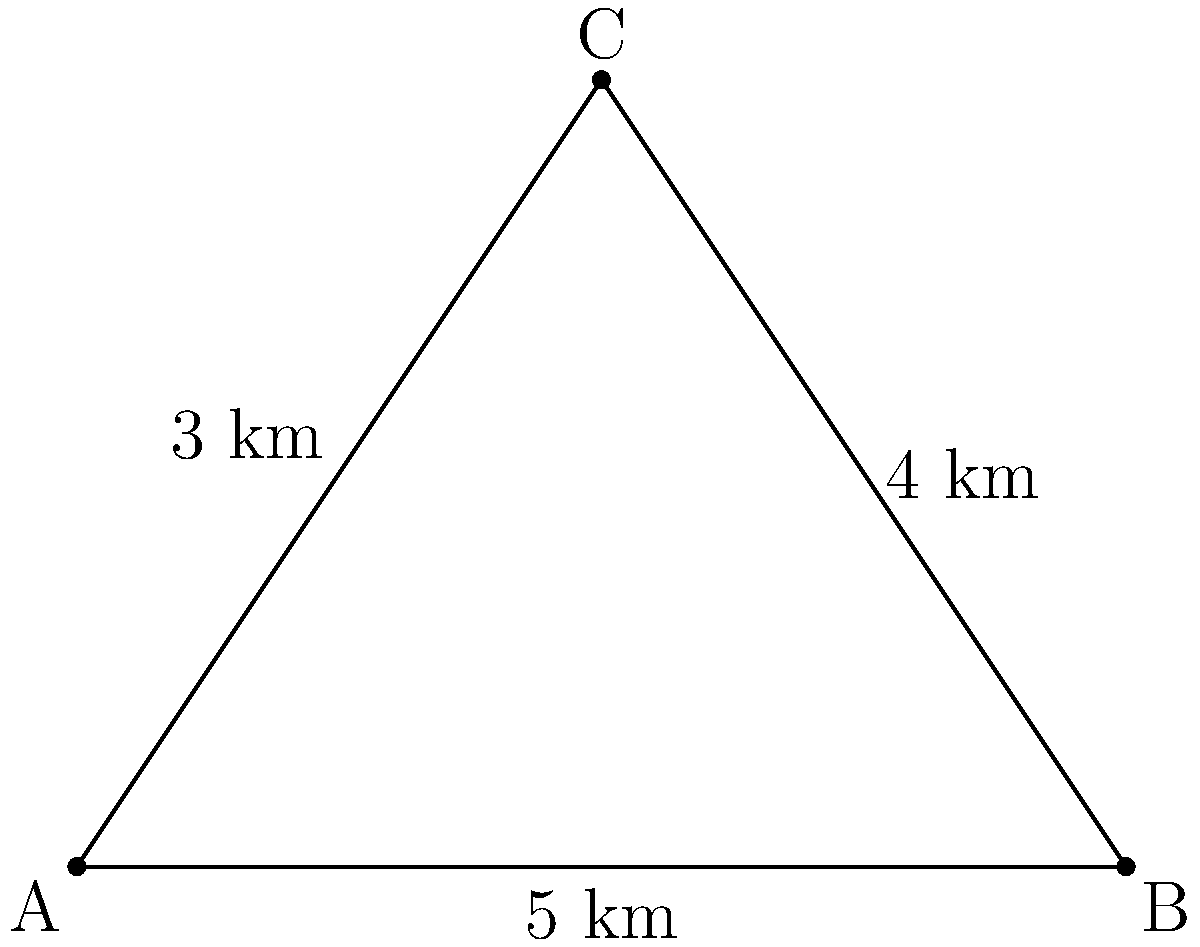In the desert near Riyadh, two roads intersect at point C. The first road runs from A to B, and the second road connects C to A. If the distance from A to B is 5 km, from B to C is 4 km, and from A to C is 3 km, what is the angle between these two roads at point C? To find the angle between the two roads at point C, we can use the law of cosines. Here's how:

1) Let's denote the angle at C as $\theta$.

2) The law of cosines states: 
   $c^2 = a^2 + b^2 - 2ab \cos(C)$
   where $c$ is the side opposite to angle C, and $a$ and $b$ are the other two sides.

3) In our case:
   $a = 3$ km (AC)
   $b = 4$ km (BC)
   $c = 5$ km (AB)

4) Substituting these values into the formula:
   $5^2 = 3^2 + 4^2 - 2(3)(4) \cos(\theta)$

5) Simplify:
   $25 = 9 + 16 - 24 \cos(\theta)$
   $25 = 25 - 24 \cos(\theta)$

6) Solve for $\cos(\theta)$:
   $24 \cos(\theta) = 0$
   $\cos(\theta) = 0$

7) To find $\theta$, we take the inverse cosine (arccos) of both sides:
   $\theta = \arccos(0) = 90°$

Therefore, the angle between the two roads at point C is 90°.
Answer: 90° 